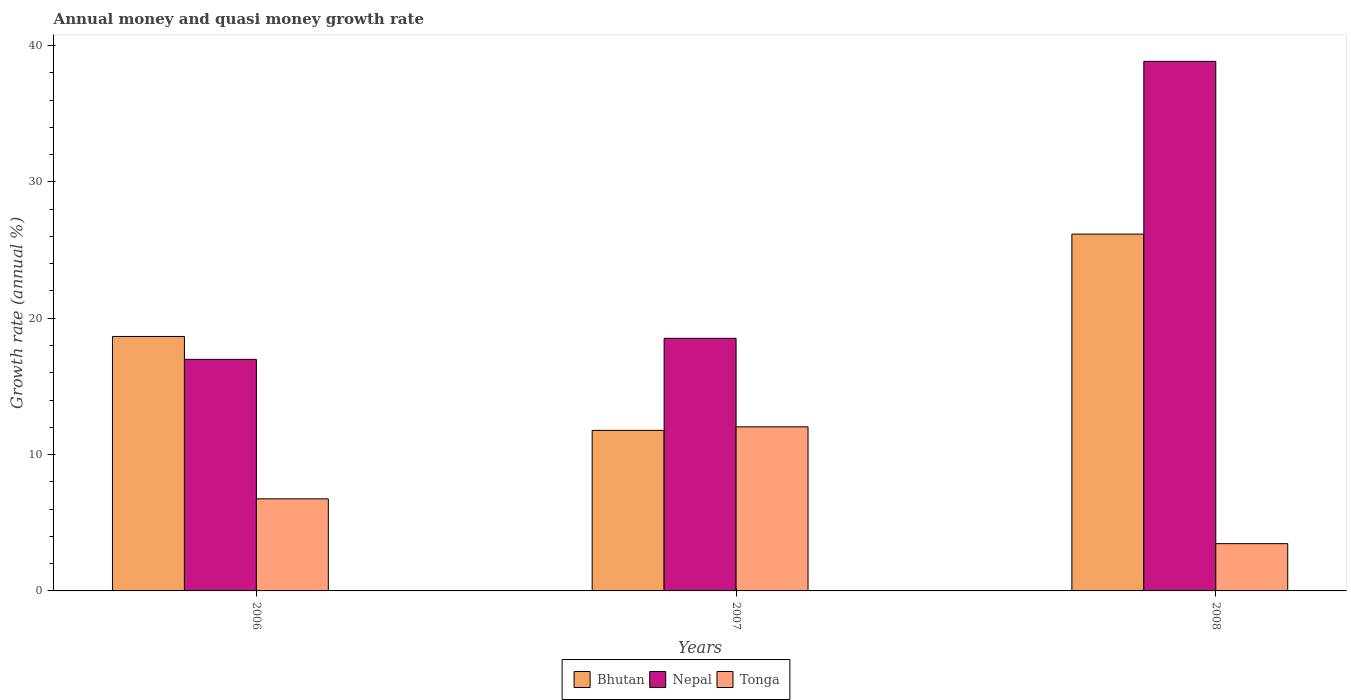Are the number of bars per tick equal to the number of legend labels?
Provide a short and direct response. Yes. How many bars are there on the 1st tick from the right?
Your answer should be very brief. 3. What is the growth rate in Tonga in 2008?
Ensure brevity in your answer.  3.47. Across all years, what is the maximum growth rate in Tonga?
Ensure brevity in your answer.  12.03. Across all years, what is the minimum growth rate in Tonga?
Ensure brevity in your answer.  3.47. In which year was the growth rate in Bhutan maximum?
Your answer should be very brief. 2008. What is the total growth rate in Bhutan in the graph?
Your response must be concise. 56.61. What is the difference between the growth rate in Nepal in 2007 and that in 2008?
Keep it short and to the point. -20.31. What is the difference between the growth rate in Bhutan in 2007 and the growth rate in Tonga in 2006?
Your answer should be compact. 5.02. What is the average growth rate in Bhutan per year?
Give a very brief answer. 18.87. In the year 2007, what is the difference between the growth rate in Tonga and growth rate in Bhutan?
Make the answer very short. 0.26. What is the ratio of the growth rate in Tonga in 2006 to that in 2007?
Offer a terse response. 0.56. Is the growth rate in Tonga in 2006 less than that in 2007?
Offer a terse response. Yes. Is the difference between the growth rate in Tonga in 2007 and 2008 greater than the difference between the growth rate in Bhutan in 2007 and 2008?
Ensure brevity in your answer.  Yes. What is the difference between the highest and the second highest growth rate in Bhutan?
Keep it short and to the point. 7.51. What is the difference between the highest and the lowest growth rate in Tonga?
Ensure brevity in your answer.  8.57. Is the sum of the growth rate in Tonga in 2006 and 2008 greater than the maximum growth rate in Bhutan across all years?
Make the answer very short. No. What does the 1st bar from the left in 2008 represents?
Provide a succinct answer. Bhutan. What does the 3rd bar from the right in 2007 represents?
Your answer should be very brief. Bhutan. Is it the case that in every year, the sum of the growth rate in Bhutan and growth rate in Nepal is greater than the growth rate in Tonga?
Give a very brief answer. Yes. How many bars are there?
Offer a very short reply. 9. How many years are there in the graph?
Offer a terse response. 3. What is the difference between two consecutive major ticks on the Y-axis?
Provide a short and direct response. 10. Are the values on the major ticks of Y-axis written in scientific E-notation?
Provide a succinct answer. No. Does the graph contain any zero values?
Provide a succinct answer. No. Does the graph contain grids?
Offer a very short reply. No. How are the legend labels stacked?
Your answer should be compact. Horizontal. What is the title of the graph?
Make the answer very short. Annual money and quasi money growth rate. What is the label or title of the X-axis?
Offer a very short reply. Years. What is the label or title of the Y-axis?
Provide a succinct answer. Growth rate (annual %). What is the Growth rate (annual %) in Bhutan in 2006?
Your answer should be compact. 18.66. What is the Growth rate (annual %) of Nepal in 2006?
Give a very brief answer. 16.99. What is the Growth rate (annual %) of Tonga in 2006?
Your answer should be very brief. 6.75. What is the Growth rate (annual %) of Bhutan in 2007?
Your response must be concise. 11.78. What is the Growth rate (annual %) of Nepal in 2007?
Make the answer very short. 18.53. What is the Growth rate (annual %) of Tonga in 2007?
Ensure brevity in your answer.  12.03. What is the Growth rate (annual %) in Bhutan in 2008?
Provide a short and direct response. 26.17. What is the Growth rate (annual %) of Nepal in 2008?
Your answer should be compact. 38.84. What is the Growth rate (annual %) in Tonga in 2008?
Offer a very short reply. 3.47. Across all years, what is the maximum Growth rate (annual %) in Bhutan?
Your response must be concise. 26.17. Across all years, what is the maximum Growth rate (annual %) in Nepal?
Ensure brevity in your answer.  38.84. Across all years, what is the maximum Growth rate (annual %) of Tonga?
Give a very brief answer. 12.03. Across all years, what is the minimum Growth rate (annual %) of Bhutan?
Your answer should be very brief. 11.78. Across all years, what is the minimum Growth rate (annual %) in Nepal?
Make the answer very short. 16.99. Across all years, what is the minimum Growth rate (annual %) of Tonga?
Provide a succinct answer. 3.47. What is the total Growth rate (annual %) in Bhutan in the graph?
Provide a succinct answer. 56.61. What is the total Growth rate (annual %) in Nepal in the graph?
Give a very brief answer. 74.35. What is the total Growth rate (annual %) of Tonga in the graph?
Make the answer very short. 22.25. What is the difference between the Growth rate (annual %) in Bhutan in 2006 and that in 2007?
Ensure brevity in your answer.  6.89. What is the difference between the Growth rate (annual %) in Nepal in 2006 and that in 2007?
Make the answer very short. -1.54. What is the difference between the Growth rate (annual %) of Tonga in 2006 and that in 2007?
Provide a succinct answer. -5.28. What is the difference between the Growth rate (annual %) in Bhutan in 2006 and that in 2008?
Make the answer very short. -7.51. What is the difference between the Growth rate (annual %) in Nepal in 2006 and that in 2008?
Offer a very short reply. -21.86. What is the difference between the Growth rate (annual %) of Tonga in 2006 and that in 2008?
Make the answer very short. 3.29. What is the difference between the Growth rate (annual %) of Bhutan in 2007 and that in 2008?
Ensure brevity in your answer.  -14.4. What is the difference between the Growth rate (annual %) in Nepal in 2007 and that in 2008?
Your answer should be compact. -20.31. What is the difference between the Growth rate (annual %) of Tonga in 2007 and that in 2008?
Give a very brief answer. 8.57. What is the difference between the Growth rate (annual %) in Bhutan in 2006 and the Growth rate (annual %) in Nepal in 2007?
Your answer should be very brief. 0.13. What is the difference between the Growth rate (annual %) in Bhutan in 2006 and the Growth rate (annual %) in Tonga in 2007?
Your answer should be compact. 6.63. What is the difference between the Growth rate (annual %) of Nepal in 2006 and the Growth rate (annual %) of Tonga in 2007?
Offer a terse response. 4.95. What is the difference between the Growth rate (annual %) in Bhutan in 2006 and the Growth rate (annual %) in Nepal in 2008?
Your answer should be compact. -20.18. What is the difference between the Growth rate (annual %) of Bhutan in 2006 and the Growth rate (annual %) of Tonga in 2008?
Your answer should be very brief. 15.2. What is the difference between the Growth rate (annual %) in Nepal in 2006 and the Growth rate (annual %) in Tonga in 2008?
Keep it short and to the point. 13.52. What is the difference between the Growth rate (annual %) in Bhutan in 2007 and the Growth rate (annual %) in Nepal in 2008?
Provide a succinct answer. -27.07. What is the difference between the Growth rate (annual %) of Bhutan in 2007 and the Growth rate (annual %) of Tonga in 2008?
Give a very brief answer. 8.31. What is the difference between the Growth rate (annual %) of Nepal in 2007 and the Growth rate (annual %) of Tonga in 2008?
Keep it short and to the point. 15.06. What is the average Growth rate (annual %) in Bhutan per year?
Your answer should be very brief. 18.87. What is the average Growth rate (annual %) in Nepal per year?
Offer a very short reply. 24.79. What is the average Growth rate (annual %) in Tonga per year?
Your response must be concise. 7.42. In the year 2006, what is the difference between the Growth rate (annual %) in Bhutan and Growth rate (annual %) in Nepal?
Offer a terse response. 1.68. In the year 2006, what is the difference between the Growth rate (annual %) of Bhutan and Growth rate (annual %) of Tonga?
Your response must be concise. 11.91. In the year 2006, what is the difference between the Growth rate (annual %) of Nepal and Growth rate (annual %) of Tonga?
Your answer should be compact. 10.23. In the year 2007, what is the difference between the Growth rate (annual %) in Bhutan and Growth rate (annual %) in Nepal?
Your answer should be compact. -6.75. In the year 2007, what is the difference between the Growth rate (annual %) in Bhutan and Growth rate (annual %) in Tonga?
Your answer should be compact. -0.26. In the year 2007, what is the difference between the Growth rate (annual %) in Nepal and Growth rate (annual %) in Tonga?
Your answer should be compact. 6.49. In the year 2008, what is the difference between the Growth rate (annual %) in Bhutan and Growth rate (annual %) in Nepal?
Your response must be concise. -12.67. In the year 2008, what is the difference between the Growth rate (annual %) in Bhutan and Growth rate (annual %) in Tonga?
Offer a terse response. 22.7. In the year 2008, what is the difference between the Growth rate (annual %) of Nepal and Growth rate (annual %) of Tonga?
Give a very brief answer. 35.37. What is the ratio of the Growth rate (annual %) of Bhutan in 2006 to that in 2007?
Offer a terse response. 1.58. What is the ratio of the Growth rate (annual %) in Tonga in 2006 to that in 2007?
Your answer should be very brief. 0.56. What is the ratio of the Growth rate (annual %) in Bhutan in 2006 to that in 2008?
Ensure brevity in your answer.  0.71. What is the ratio of the Growth rate (annual %) of Nepal in 2006 to that in 2008?
Keep it short and to the point. 0.44. What is the ratio of the Growth rate (annual %) in Tonga in 2006 to that in 2008?
Make the answer very short. 1.95. What is the ratio of the Growth rate (annual %) in Bhutan in 2007 to that in 2008?
Offer a very short reply. 0.45. What is the ratio of the Growth rate (annual %) of Nepal in 2007 to that in 2008?
Keep it short and to the point. 0.48. What is the ratio of the Growth rate (annual %) in Tonga in 2007 to that in 2008?
Your answer should be compact. 3.47. What is the difference between the highest and the second highest Growth rate (annual %) in Bhutan?
Keep it short and to the point. 7.51. What is the difference between the highest and the second highest Growth rate (annual %) of Nepal?
Your answer should be compact. 20.31. What is the difference between the highest and the second highest Growth rate (annual %) in Tonga?
Your response must be concise. 5.28. What is the difference between the highest and the lowest Growth rate (annual %) in Bhutan?
Your response must be concise. 14.4. What is the difference between the highest and the lowest Growth rate (annual %) of Nepal?
Provide a succinct answer. 21.86. What is the difference between the highest and the lowest Growth rate (annual %) in Tonga?
Give a very brief answer. 8.57. 